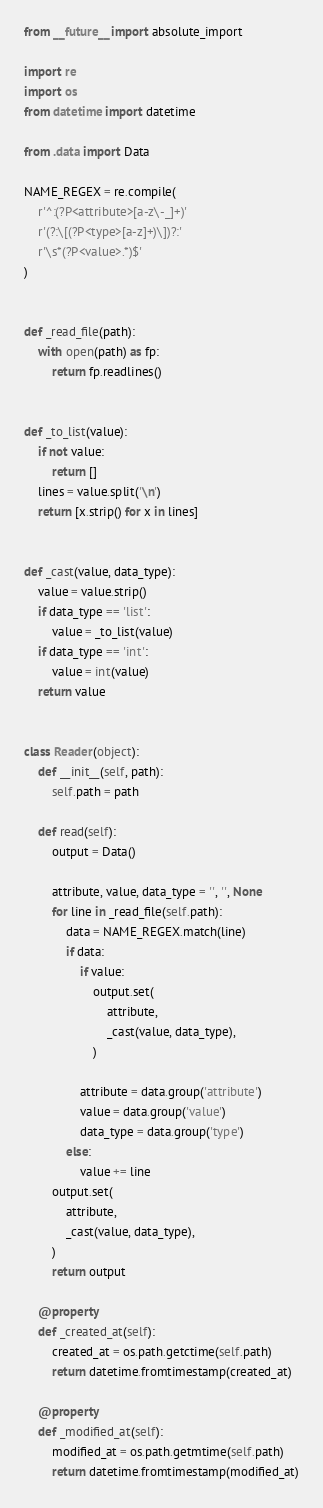Convert code to text. <code><loc_0><loc_0><loc_500><loc_500><_Python_>from __future__ import absolute_import

import re
import os
from datetime import datetime

from .data import Data

NAME_REGEX = re.compile(
    r'^:(?P<attribute>[a-z\-_]+)'
    r'(?:\[(?P<type>[a-z]+)\])?:'
    r'\s*(?P<value>.*)$'
)


def _read_file(path):
    with open(path) as fp:
        return fp.readlines()


def _to_list(value):
    if not value:
        return []
    lines = value.split('\n')
    return [x.strip() for x in lines]


def _cast(value, data_type):
    value = value.strip()
    if data_type == 'list':
        value = _to_list(value)
    if data_type == 'int':
        value = int(value)
    return value


class Reader(object):
    def __init__(self, path):
        self.path = path

    def read(self):
        output = Data()

        attribute, value, data_type = '', '', None
        for line in _read_file(self.path):
            data = NAME_REGEX.match(line)
            if data:
                if value:
                    output.set(
                        attribute,
                        _cast(value, data_type),
                    )

                attribute = data.group('attribute')
                value = data.group('value')
                data_type = data.group('type')
            else:
                value += line
        output.set(
            attribute,
            _cast(value, data_type),
        )
        return output

    @property
    def _created_at(self):
        created_at = os.path.getctime(self.path)
        return datetime.fromtimestamp(created_at)

    @property
    def _modified_at(self):
        modified_at = os.path.getmtime(self.path)
        return datetime.fromtimestamp(modified_at)
</code> 